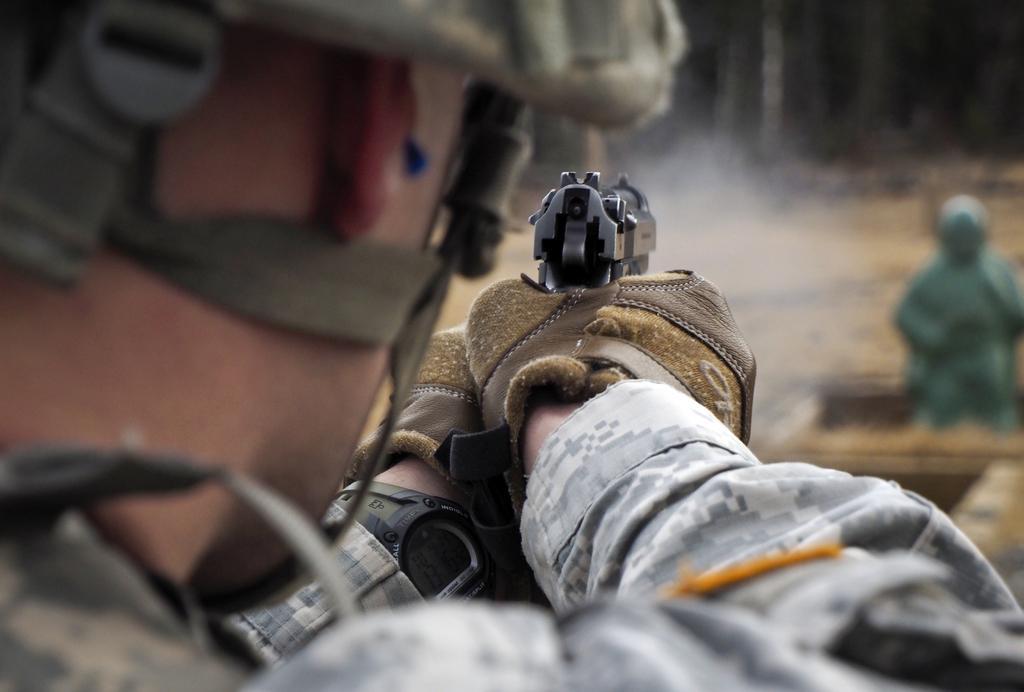Describe this image in one or two sentences. In this image, we can see a man standing and he is holding a gun and there is a blur background. 